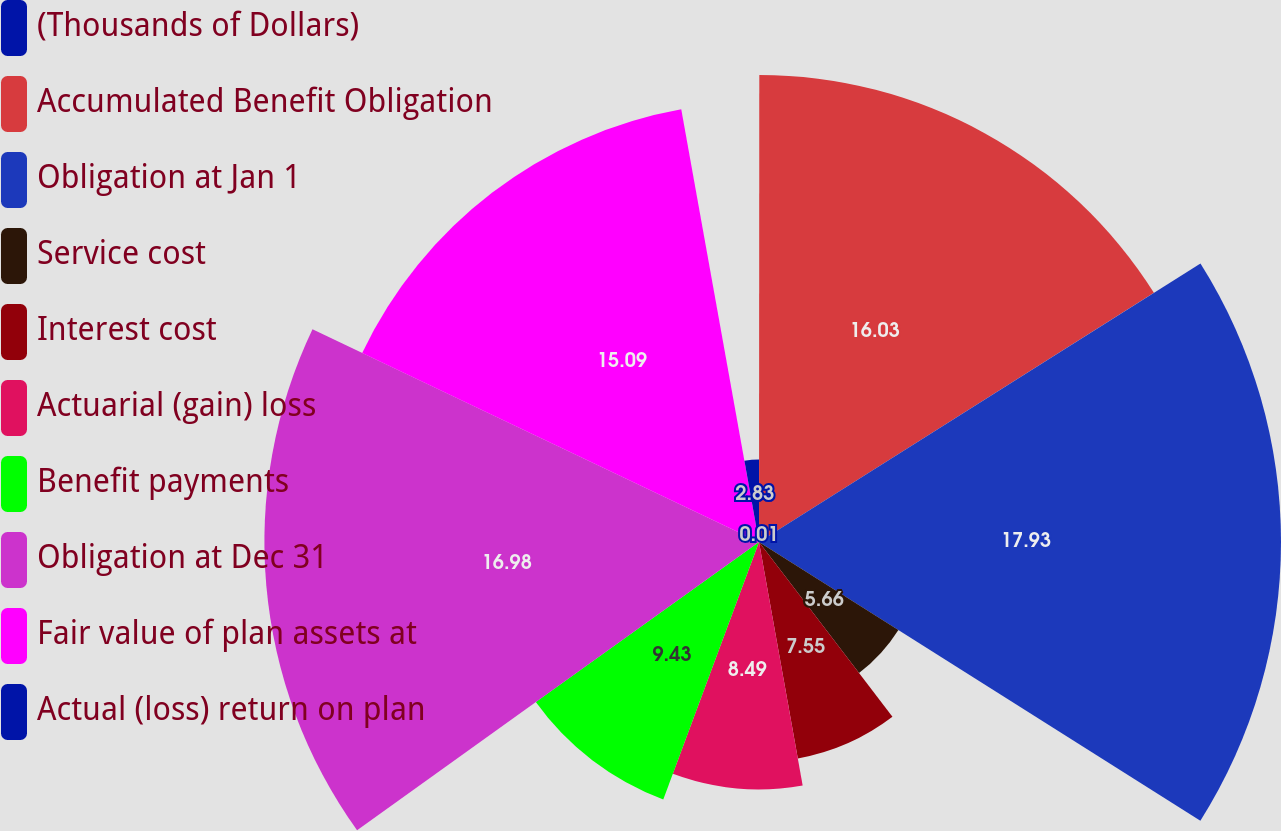Convert chart to OTSL. <chart><loc_0><loc_0><loc_500><loc_500><pie_chart><fcel>(Thousands of Dollars)<fcel>Accumulated Benefit Obligation<fcel>Obligation at Jan 1<fcel>Service cost<fcel>Interest cost<fcel>Actuarial (gain) loss<fcel>Benefit payments<fcel>Obligation at Dec 31<fcel>Fair value of plan assets at<fcel>Actual (loss) return on plan<nl><fcel>0.01%<fcel>16.03%<fcel>17.92%<fcel>5.66%<fcel>7.55%<fcel>8.49%<fcel>9.43%<fcel>16.98%<fcel>15.09%<fcel>2.83%<nl></chart> 